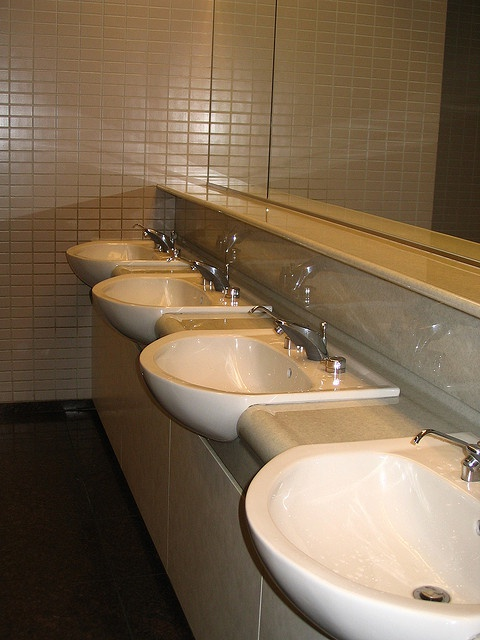Describe the objects in this image and their specific colors. I can see sink in gray, lightgray, tan, and darkgray tones, sink in gray and tan tones, sink in gray and tan tones, and sink in gray, tan, olive, and maroon tones in this image. 